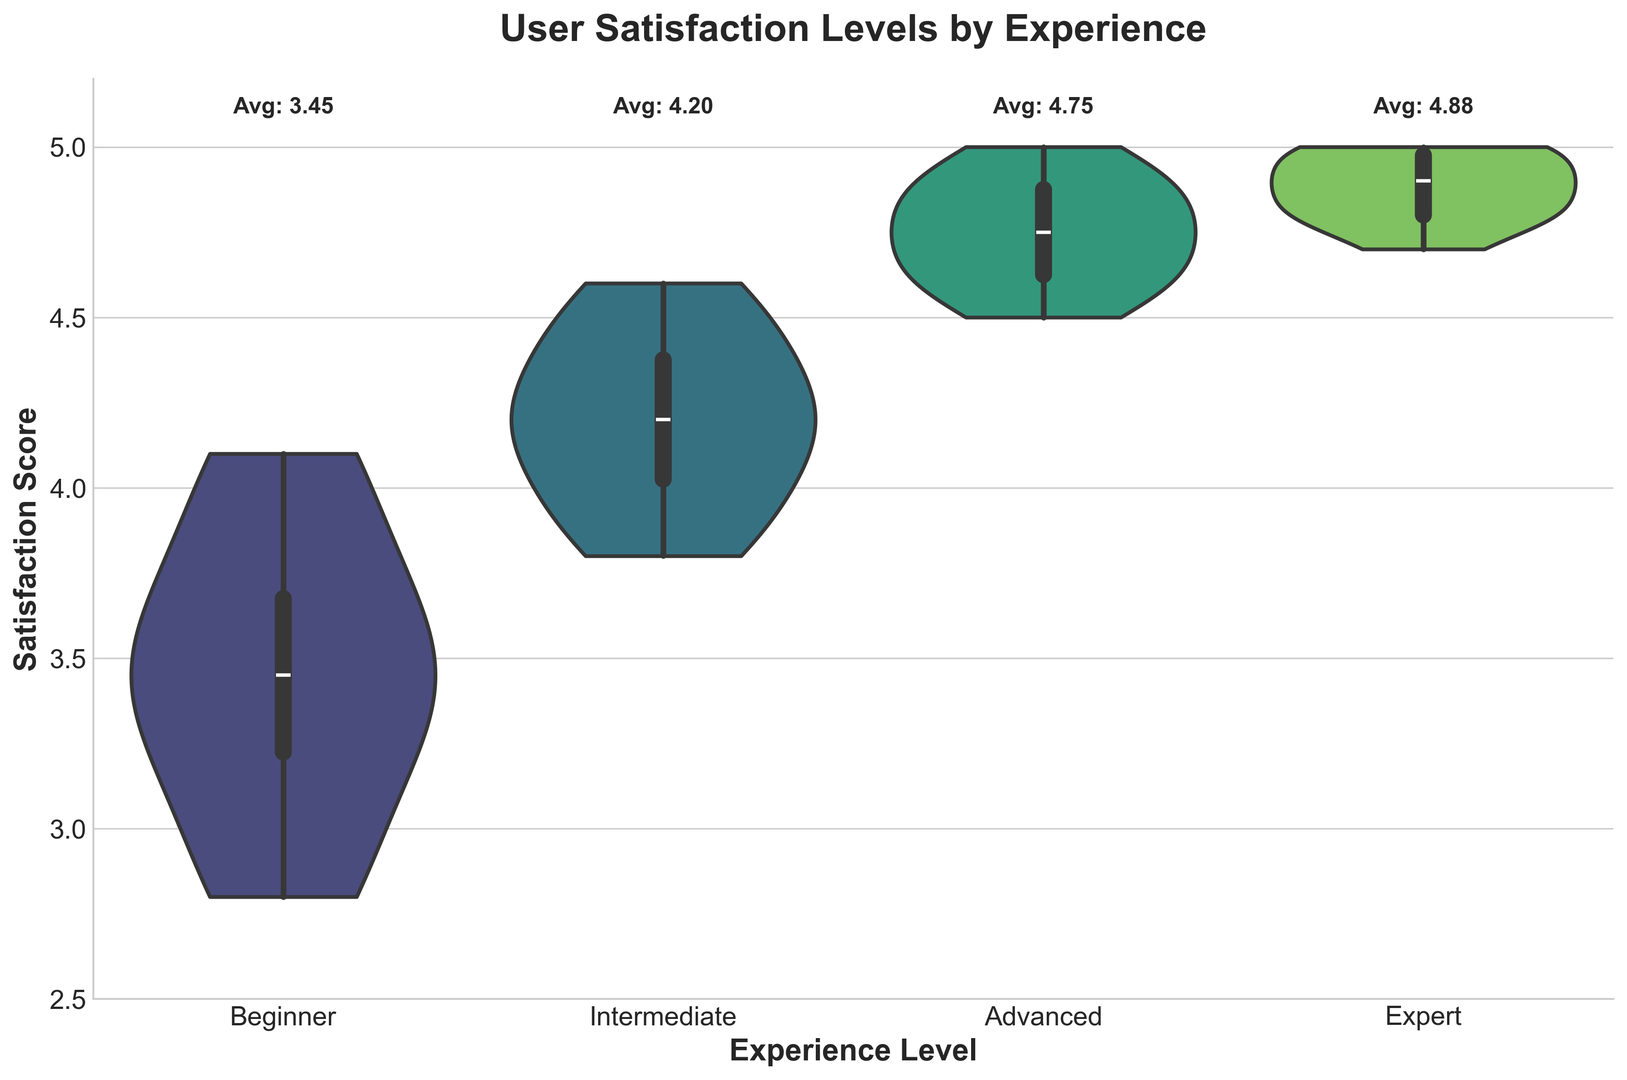What is the average satisfaction score for Intermediate users? Look at the text above the violin plot for Intermediate users, which indicates the average satisfaction score.
Answer: 4.20 Which experience level group has the highest average satisfaction score? Compare the text above each violin plot indicating the average satisfaction scores. The group with the highest average is the one with the highest numeric value.
Answer: Expert Does the Beginner group have more spread in satisfaction scores compared to the Expert group? Observe the width of the violet plots for both the Beginner and Expert groups. A wider plot indicates more spread.
Answer: Yes Which experience level group has the smallest variability in satisfaction scores? Look at the width of the violin plots. The narrowest plot indicates the smallest variability.
Answer: Expert What is the range of satisfaction scores for the Advanced user group? Note the upper and lower ends of the violin plot for the Advanced group and subtract the smallest value from the largest value.
Answer: 4.6 to 5.0 How does the median satisfaction score compare between Beginner and Advanced users? Identify the white dot or line in the middle of each violin plot, which represents the median. Compare the positions of these dots/lines between the two groups.
Answer: The median score is higher for Advanced users Between which two user groups is the difference in average satisfaction scores the smallest? Compare the average satisfaction scores (numbers above the violin plots) for all adjacent pairs and identify the smallest difference.
Answer: Intermediate and Advanced Which user experience level shows a box plot within the violin plot that is situated higher on the satisfaction scale? Look within the violin plots for the box plot (the white box) and see which is positioned higher on the vertical scale.
Answer: Expert Is there any overlap in the satisfaction scores distribution between the Intermediate and Advanced user groups? Compare the violin plots of the Intermediate and Advanced groups to see if their distribution ranges overlap.
Answer: Yes 